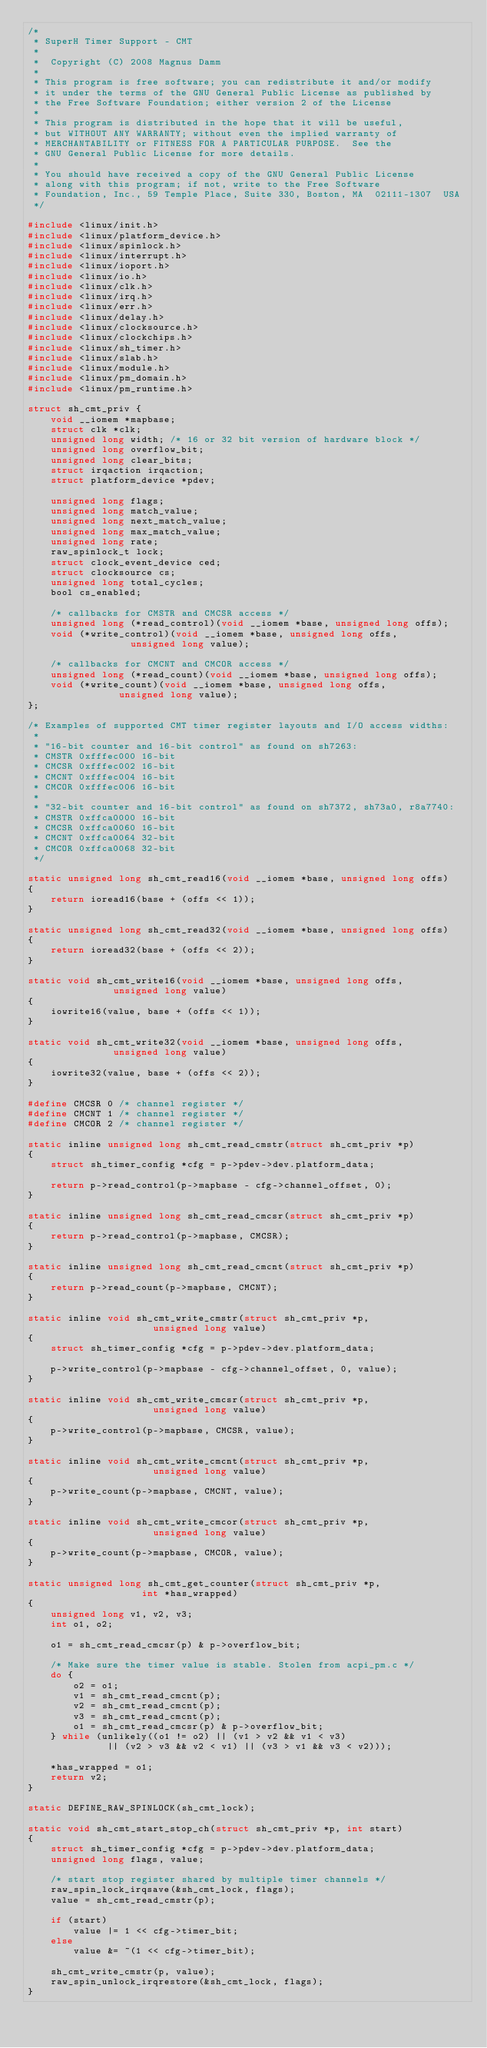Convert code to text. <code><loc_0><loc_0><loc_500><loc_500><_C_>/*
 * SuperH Timer Support - CMT
 *
 *  Copyright (C) 2008 Magnus Damm
 *
 * This program is free software; you can redistribute it and/or modify
 * it under the terms of the GNU General Public License as published by
 * the Free Software Foundation; either version 2 of the License
 *
 * This program is distributed in the hope that it will be useful,
 * but WITHOUT ANY WARRANTY; without even the implied warranty of
 * MERCHANTABILITY or FITNESS FOR A PARTICULAR PURPOSE.  See the
 * GNU General Public License for more details.
 *
 * You should have received a copy of the GNU General Public License
 * along with this program; if not, write to the Free Software
 * Foundation, Inc., 59 Temple Place, Suite 330, Boston, MA  02111-1307  USA
 */

#include <linux/init.h>
#include <linux/platform_device.h>
#include <linux/spinlock.h>
#include <linux/interrupt.h>
#include <linux/ioport.h>
#include <linux/io.h>
#include <linux/clk.h>
#include <linux/irq.h>
#include <linux/err.h>
#include <linux/delay.h>
#include <linux/clocksource.h>
#include <linux/clockchips.h>
#include <linux/sh_timer.h>
#include <linux/slab.h>
#include <linux/module.h>
#include <linux/pm_domain.h>
#include <linux/pm_runtime.h>

struct sh_cmt_priv {
	void __iomem *mapbase;
	struct clk *clk;
	unsigned long width; /* 16 or 32 bit version of hardware block */
	unsigned long overflow_bit;
	unsigned long clear_bits;
	struct irqaction irqaction;
	struct platform_device *pdev;

	unsigned long flags;
	unsigned long match_value;
	unsigned long next_match_value;
	unsigned long max_match_value;
	unsigned long rate;
	raw_spinlock_t lock;
	struct clock_event_device ced;
	struct clocksource cs;
	unsigned long total_cycles;
	bool cs_enabled;

	/* callbacks for CMSTR and CMCSR access */
	unsigned long (*read_control)(void __iomem *base, unsigned long offs);
	void (*write_control)(void __iomem *base, unsigned long offs,
			      unsigned long value);

	/* callbacks for CMCNT and CMCOR access */
	unsigned long (*read_count)(void __iomem *base, unsigned long offs);
	void (*write_count)(void __iomem *base, unsigned long offs,
			    unsigned long value);
};

/* Examples of supported CMT timer register layouts and I/O access widths:
 *
 * "16-bit counter and 16-bit control" as found on sh7263:
 * CMSTR 0xfffec000 16-bit
 * CMCSR 0xfffec002 16-bit
 * CMCNT 0xfffec004 16-bit
 * CMCOR 0xfffec006 16-bit
 *
 * "32-bit counter and 16-bit control" as found on sh7372, sh73a0, r8a7740:
 * CMSTR 0xffca0000 16-bit
 * CMCSR 0xffca0060 16-bit
 * CMCNT 0xffca0064 32-bit
 * CMCOR 0xffca0068 32-bit
 */

static unsigned long sh_cmt_read16(void __iomem *base, unsigned long offs)
{
	return ioread16(base + (offs << 1));
}

static unsigned long sh_cmt_read32(void __iomem *base, unsigned long offs)
{
	return ioread32(base + (offs << 2));
}

static void sh_cmt_write16(void __iomem *base, unsigned long offs,
			   unsigned long value)
{
	iowrite16(value, base + (offs << 1));
}

static void sh_cmt_write32(void __iomem *base, unsigned long offs,
			   unsigned long value)
{
	iowrite32(value, base + (offs << 2));
}

#define CMCSR 0 /* channel register */
#define CMCNT 1 /* channel register */
#define CMCOR 2 /* channel register */

static inline unsigned long sh_cmt_read_cmstr(struct sh_cmt_priv *p)
{
	struct sh_timer_config *cfg = p->pdev->dev.platform_data;

	return p->read_control(p->mapbase - cfg->channel_offset, 0);
}

static inline unsigned long sh_cmt_read_cmcsr(struct sh_cmt_priv *p)
{
	return p->read_control(p->mapbase, CMCSR);
}

static inline unsigned long sh_cmt_read_cmcnt(struct sh_cmt_priv *p)
{
	return p->read_count(p->mapbase, CMCNT);
}

static inline void sh_cmt_write_cmstr(struct sh_cmt_priv *p,
				      unsigned long value)
{
	struct sh_timer_config *cfg = p->pdev->dev.platform_data;

	p->write_control(p->mapbase - cfg->channel_offset, 0, value);
}

static inline void sh_cmt_write_cmcsr(struct sh_cmt_priv *p,
				      unsigned long value)
{
	p->write_control(p->mapbase, CMCSR, value);
}

static inline void sh_cmt_write_cmcnt(struct sh_cmt_priv *p,
				      unsigned long value)
{
	p->write_count(p->mapbase, CMCNT, value);
}

static inline void sh_cmt_write_cmcor(struct sh_cmt_priv *p,
				      unsigned long value)
{
	p->write_count(p->mapbase, CMCOR, value);
}

static unsigned long sh_cmt_get_counter(struct sh_cmt_priv *p,
					int *has_wrapped)
{
	unsigned long v1, v2, v3;
	int o1, o2;

	o1 = sh_cmt_read_cmcsr(p) & p->overflow_bit;

	/* Make sure the timer value is stable. Stolen from acpi_pm.c */
	do {
		o2 = o1;
		v1 = sh_cmt_read_cmcnt(p);
		v2 = sh_cmt_read_cmcnt(p);
		v3 = sh_cmt_read_cmcnt(p);
		o1 = sh_cmt_read_cmcsr(p) & p->overflow_bit;
	} while (unlikely((o1 != o2) || (v1 > v2 && v1 < v3)
			  || (v2 > v3 && v2 < v1) || (v3 > v1 && v3 < v2)));

	*has_wrapped = o1;
	return v2;
}

static DEFINE_RAW_SPINLOCK(sh_cmt_lock);

static void sh_cmt_start_stop_ch(struct sh_cmt_priv *p, int start)
{
	struct sh_timer_config *cfg = p->pdev->dev.platform_data;
	unsigned long flags, value;

	/* start stop register shared by multiple timer channels */
	raw_spin_lock_irqsave(&sh_cmt_lock, flags);
	value = sh_cmt_read_cmstr(p);

	if (start)
		value |= 1 << cfg->timer_bit;
	else
		value &= ~(1 << cfg->timer_bit);

	sh_cmt_write_cmstr(p, value);
	raw_spin_unlock_irqrestore(&sh_cmt_lock, flags);
}
</code> 